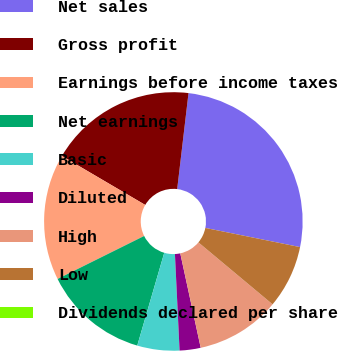Convert chart. <chart><loc_0><loc_0><loc_500><loc_500><pie_chart><fcel>Net sales<fcel>Gross profit<fcel>Earnings before income taxes<fcel>Net earnings<fcel>Basic<fcel>Diluted<fcel>High<fcel>Low<fcel>Dividends declared per share<nl><fcel>26.31%<fcel>18.42%<fcel>15.79%<fcel>13.16%<fcel>5.27%<fcel>2.63%<fcel>10.53%<fcel>7.9%<fcel>0.0%<nl></chart> 